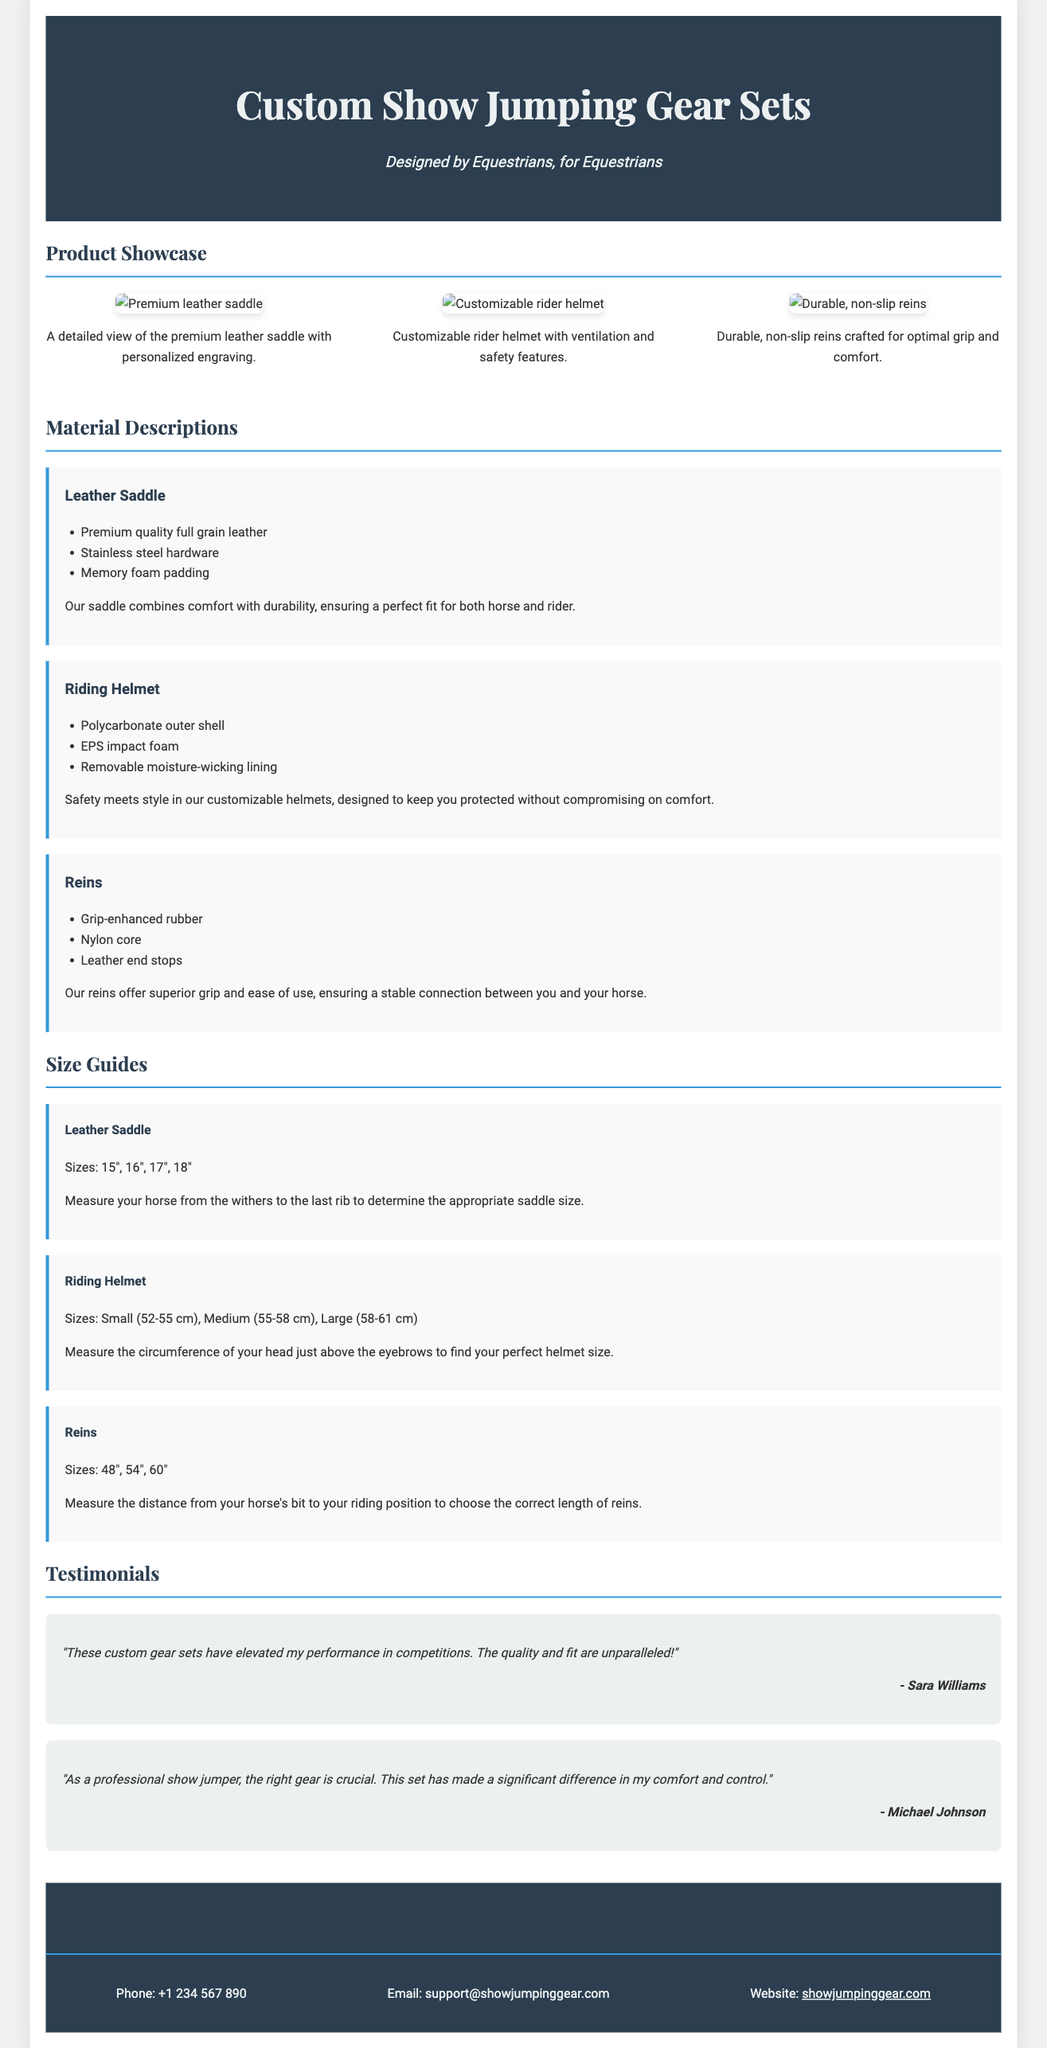What is the product title? The product title is found in the header of the document.
Answer: Custom Show Jumping Gear Sets Who designed the gear? The subtitle indicates the designers of the gear.
Answer: Designed by Equestrians What material is the riding helmet made from? The material description section lists the helmet's materials.
Answer: Polycarbonate outer shell What size options are available for the leather saddle? The size guide section specifies the saddle sizes.
Answer: 15", 16", 17", 18" How many images are displayed in the product showcase? The image gallery visually showcases the number of images.
Answer: 3 What feature is highlighted for the reins? The material descriptions section mentions a unique feature.
Answer: Grip-enhanced rubber Who provided a testimonial about the gear sets? The testimonials section lists the names of the authors.
Answer: Sara Williams How can customers contact support? The contact section provides methods for communication.
Answer: Phone: +1 234 567 890 What is a key benefit of the premium leather saddle? The material description indicates a benefit of the saddle.
Answer: Comfort with durability 